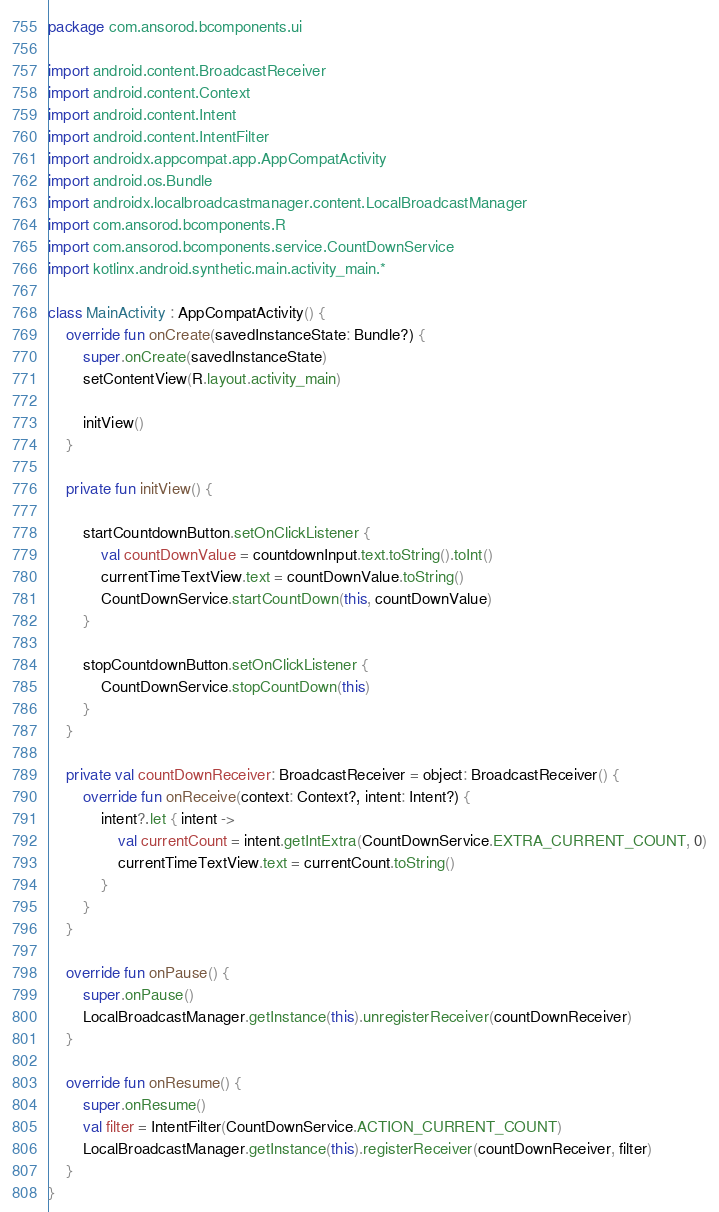Convert code to text. <code><loc_0><loc_0><loc_500><loc_500><_Kotlin_>package com.ansorod.bcomponents.ui

import android.content.BroadcastReceiver
import android.content.Context
import android.content.Intent
import android.content.IntentFilter
import androidx.appcompat.app.AppCompatActivity
import android.os.Bundle
import androidx.localbroadcastmanager.content.LocalBroadcastManager
import com.ansorod.bcomponents.R
import com.ansorod.bcomponents.service.CountDownService
import kotlinx.android.synthetic.main.activity_main.*

class MainActivity : AppCompatActivity() {
    override fun onCreate(savedInstanceState: Bundle?) {
        super.onCreate(savedInstanceState)
        setContentView(R.layout.activity_main)

        initView()
    }

    private fun initView() {

        startCountdownButton.setOnClickListener {
            val countDownValue = countdownInput.text.toString().toInt()
            currentTimeTextView.text = countDownValue.toString()
            CountDownService.startCountDown(this, countDownValue)
        }

        stopCountdownButton.setOnClickListener {
            CountDownService.stopCountDown(this)
        }
    }

    private val countDownReceiver: BroadcastReceiver = object: BroadcastReceiver() {
        override fun onReceive(context: Context?, intent: Intent?) {
            intent?.let { intent ->
                val currentCount = intent.getIntExtra(CountDownService.EXTRA_CURRENT_COUNT, 0)
                currentTimeTextView.text = currentCount.toString()
            }
        }
    }

    override fun onPause() {
        super.onPause()
        LocalBroadcastManager.getInstance(this).unregisterReceiver(countDownReceiver)
    }

    override fun onResume() {
        super.onResume()
        val filter = IntentFilter(CountDownService.ACTION_CURRENT_COUNT)
        LocalBroadcastManager.getInstance(this).registerReceiver(countDownReceiver, filter)
    }
}</code> 